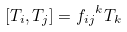<formula> <loc_0><loc_0><loc_500><loc_500>[ T _ { i } , T _ { j } ] = { f _ { i j } } ^ { k } T _ { k }</formula> 